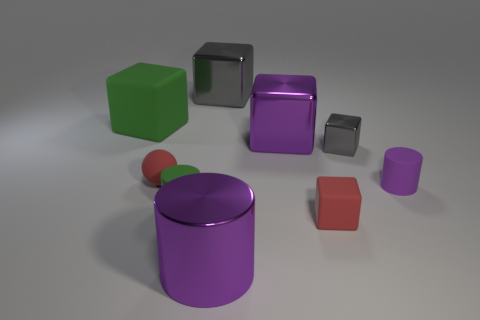Are there any big purple matte objects of the same shape as the large gray shiny thing?
Make the answer very short. No. How many objects are either shiny objects left of the tiny gray cube or tiny yellow blocks?
Offer a very short reply. 3. What size is the matte thing that is the same color as the shiny cylinder?
Offer a very short reply. Small. There is a matte cylinder that is right of the small gray metal thing; does it have the same color as the large metallic cube in front of the green matte block?
Offer a very short reply. Yes. The purple matte cylinder has what size?
Offer a terse response. Small. How many small objects are either purple cylinders or rubber cylinders?
Keep it short and to the point. 2. There is a shiny cylinder that is the same size as the green block; what color is it?
Keep it short and to the point. Purple. What number of other things are there of the same shape as the large green matte thing?
Ensure brevity in your answer.  4. Is there another large cylinder made of the same material as the large purple cylinder?
Offer a terse response. No. Does the purple cylinder in front of the small purple cylinder have the same material as the red object that is in front of the red matte ball?
Your answer should be compact. No. 